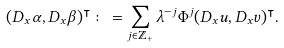Convert formula to latex. <formula><loc_0><loc_0><loc_500><loc_500>( D _ { x } \alpha , D _ { x } \beta ) ^ { \intercal } \colon = \sum _ { j \in \mathbb { Z } _ { + } } \lambda ^ { - j } \Phi ^ { j } ( D _ { x } u , D _ { x } v ) ^ { \intercal } .</formula> 